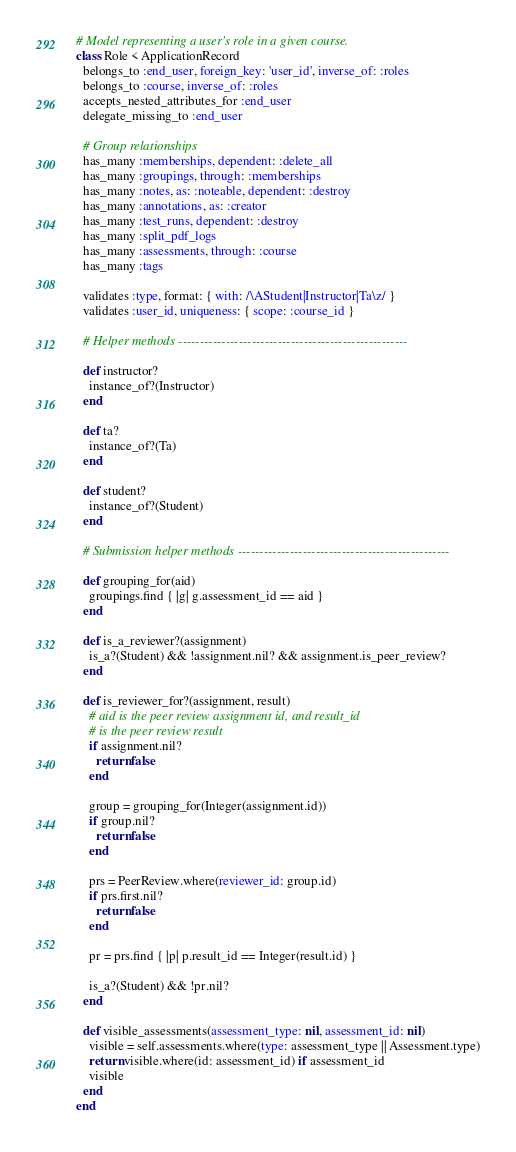Convert code to text. <code><loc_0><loc_0><loc_500><loc_500><_Ruby_># Model representing a user's role in a given course.
class Role < ApplicationRecord
  belongs_to :end_user, foreign_key: 'user_id', inverse_of: :roles
  belongs_to :course, inverse_of: :roles
  accepts_nested_attributes_for :end_user
  delegate_missing_to :end_user

  # Group relationships
  has_many :memberships, dependent: :delete_all
  has_many :groupings, through: :memberships
  has_many :notes, as: :noteable, dependent: :destroy
  has_many :annotations, as: :creator
  has_many :test_runs, dependent: :destroy
  has_many :split_pdf_logs
  has_many :assessments, through: :course
  has_many :tags

  validates :type, format: { with: /\AStudent|Instructor|Ta\z/ }
  validates :user_id, uniqueness: { scope: :course_id }

  # Helper methods -----------------------------------------------------

  def instructor?
    instance_of?(Instructor)
  end

  def ta?
    instance_of?(Ta)
  end

  def student?
    instance_of?(Student)
  end

  # Submission helper methods -------------------------------------------------

  def grouping_for(aid)
    groupings.find { |g| g.assessment_id == aid }
  end

  def is_a_reviewer?(assignment)
    is_a?(Student) && !assignment.nil? && assignment.is_peer_review?
  end

  def is_reviewer_for?(assignment, result)
    # aid is the peer review assignment id, and result_id
    # is the peer review result
    if assignment.nil?
      return false
    end

    group = grouping_for(Integer(assignment.id))
    if group.nil?
      return false
    end

    prs = PeerReview.where(reviewer_id: group.id)
    if prs.first.nil?
      return false
    end

    pr = prs.find { |p| p.result_id == Integer(result.id) }

    is_a?(Student) && !pr.nil?
  end

  def visible_assessments(assessment_type: nil, assessment_id: nil)
    visible = self.assessments.where(type: assessment_type || Assessment.type)
    return visible.where(id: assessment_id) if assessment_id
    visible
  end
end
</code> 